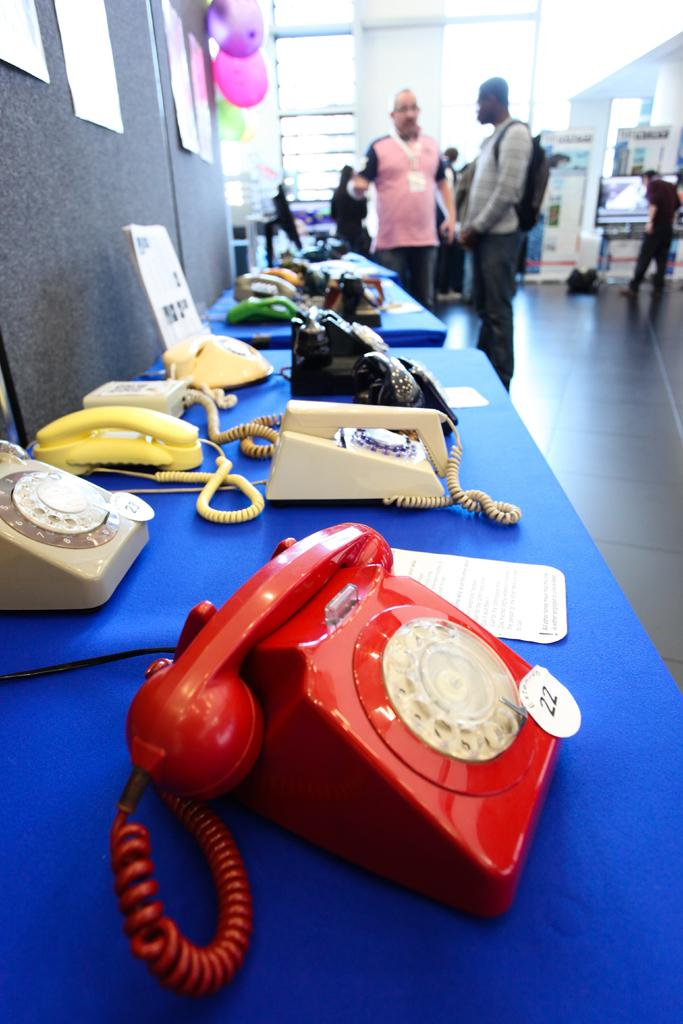What objects are on the table in the image? There are telephones and papers on the table in the image. Can you describe the people in the background of the image? Unfortunately, the provided facts do not give any information about the people in the background. What decorations are on the wall in the image? There are balloons on the wall in the image. What type of boat can be seen in the image? There is no boat present in the image. How many times did the person drop the request in the image? There is no mention of a request or dropping in the provided facts, so we cannot answer this question. 